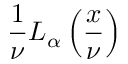Convert formula to latex. <formula><loc_0><loc_0><loc_500><loc_500>{ \frac { 1 } { \nu } } L _ { \alpha } \left ( { \frac { x } { \nu } } \right )</formula> 